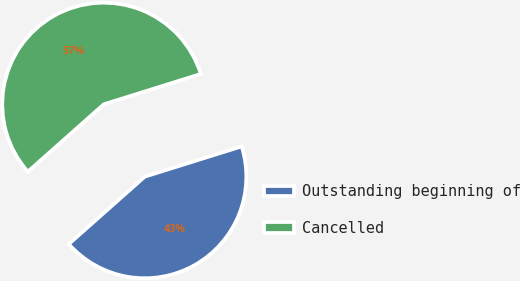Convert chart to OTSL. <chart><loc_0><loc_0><loc_500><loc_500><pie_chart><fcel>Outstanding beginning of<fcel>Cancelled<nl><fcel>43.27%<fcel>56.73%<nl></chart> 